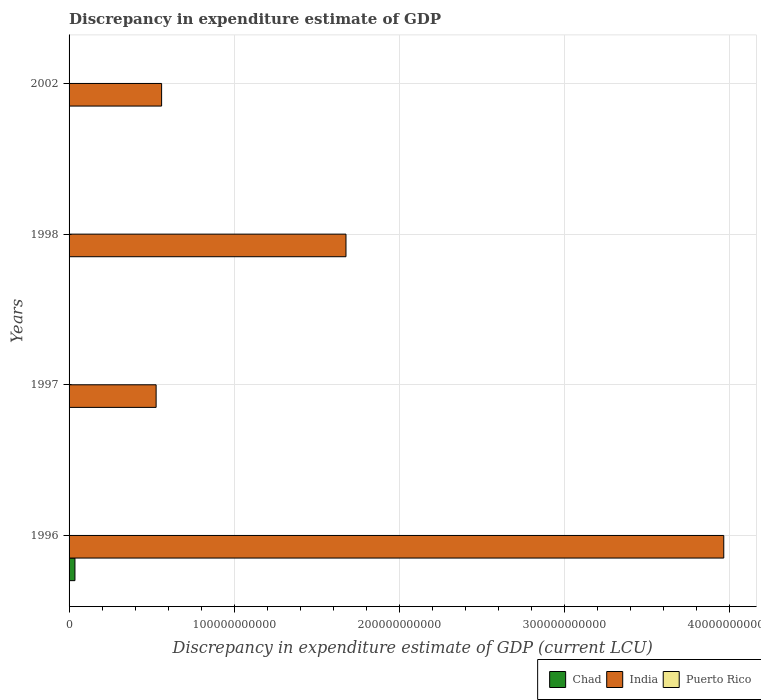How many different coloured bars are there?
Your response must be concise. 3. Are the number of bars on each tick of the Y-axis equal?
Your answer should be compact. No. What is the discrepancy in expenditure estimate of GDP in Chad in 1996?
Make the answer very short. 3.56e+09. Across all years, what is the maximum discrepancy in expenditure estimate of GDP in Chad?
Offer a very short reply. 3.56e+09. What is the total discrepancy in expenditure estimate of GDP in Puerto Rico in the graph?
Your response must be concise. 3.14e+05. What is the difference between the discrepancy in expenditure estimate of GDP in Puerto Rico in 1996 and that in 1997?
Offer a terse response. 7.70e+04. What is the difference between the discrepancy in expenditure estimate of GDP in India in 1997 and the discrepancy in expenditure estimate of GDP in Puerto Rico in 2002?
Your answer should be compact. 5.27e+1. What is the average discrepancy in expenditure estimate of GDP in India per year?
Provide a succinct answer. 1.68e+11. In the year 1996, what is the difference between the discrepancy in expenditure estimate of GDP in Chad and discrepancy in expenditure estimate of GDP in Puerto Rico?
Give a very brief answer. 3.56e+09. What is the difference between the highest and the second highest discrepancy in expenditure estimate of GDP in India?
Your answer should be compact. 2.29e+11. In how many years, is the discrepancy in expenditure estimate of GDP in India greater than the average discrepancy in expenditure estimate of GDP in India taken over all years?
Your answer should be compact. 1. Is it the case that in every year, the sum of the discrepancy in expenditure estimate of GDP in Puerto Rico and discrepancy in expenditure estimate of GDP in Chad is greater than the discrepancy in expenditure estimate of GDP in India?
Your answer should be very brief. No. How many years are there in the graph?
Your response must be concise. 4. What is the difference between two consecutive major ticks on the X-axis?
Provide a succinct answer. 1.00e+11. Are the values on the major ticks of X-axis written in scientific E-notation?
Offer a terse response. No. Does the graph contain any zero values?
Keep it short and to the point. Yes. How many legend labels are there?
Your answer should be very brief. 3. What is the title of the graph?
Offer a terse response. Discrepancy in expenditure estimate of GDP. What is the label or title of the X-axis?
Ensure brevity in your answer.  Discrepancy in expenditure estimate of GDP (current LCU). What is the label or title of the Y-axis?
Give a very brief answer. Years. What is the Discrepancy in expenditure estimate of GDP (current LCU) of Chad in 1996?
Give a very brief answer. 3.56e+09. What is the Discrepancy in expenditure estimate of GDP (current LCU) of India in 1996?
Your answer should be very brief. 3.97e+11. What is the Discrepancy in expenditure estimate of GDP (current LCU) in Puerto Rico in 1996?
Ensure brevity in your answer.  1.40e+05. What is the Discrepancy in expenditure estimate of GDP (current LCU) in Chad in 1997?
Your response must be concise. 0. What is the Discrepancy in expenditure estimate of GDP (current LCU) in India in 1997?
Offer a terse response. 5.27e+1. What is the Discrepancy in expenditure estimate of GDP (current LCU) of Puerto Rico in 1997?
Your response must be concise. 6.30e+04. What is the Discrepancy in expenditure estimate of GDP (current LCU) of India in 1998?
Offer a very short reply. 1.68e+11. What is the Discrepancy in expenditure estimate of GDP (current LCU) in Puerto Rico in 1998?
Your answer should be very brief. 1.11e+05. What is the Discrepancy in expenditure estimate of GDP (current LCU) of Chad in 2002?
Keep it short and to the point. 100. What is the Discrepancy in expenditure estimate of GDP (current LCU) of India in 2002?
Your answer should be compact. 5.61e+1. Across all years, what is the maximum Discrepancy in expenditure estimate of GDP (current LCU) in Chad?
Offer a terse response. 3.56e+09. Across all years, what is the maximum Discrepancy in expenditure estimate of GDP (current LCU) in India?
Ensure brevity in your answer.  3.97e+11. Across all years, what is the minimum Discrepancy in expenditure estimate of GDP (current LCU) of Chad?
Provide a succinct answer. 0. Across all years, what is the minimum Discrepancy in expenditure estimate of GDP (current LCU) of India?
Your response must be concise. 5.27e+1. What is the total Discrepancy in expenditure estimate of GDP (current LCU) in Chad in the graph?
Make the answer very short. 3.56e+09. What is the total Discrepancy in expenditure estimate of GDP (current LCU) of India in the graph?
Make the answer very short. 6.73e+11. What is the total Discrepancy in expenditure estimate of GDP (current LCU) of Puerto Rico in the graph?
Your answer should be compact. 3.14e+05. What is the difference between the Discrepancy in expenditure estimate of GDP (current LCU) in India in 1996 and that in 1997?
Provide a short and direct response. 3.44e+11. What is the difference between the Discrepancy in expenditure estimate of GDP (current LCU) of Puerto Rico in 1996 and that in 1997?
Your response must be concise. 7.70e+04. What is the difference between the Discrepancy in expenditure estimate of GDP (current LCU) of India in 1996 and that in 1998?
Offer a very short reply. 2.29e+11. What is the difference between the Discrepancy in expenditure estimate of GDP (current LCU) in Puerto Rico in 1996 and that in 1998?
Offer a terse response. 2.90e+04. What is the difference between the Discrepancy in expenditure estimate of GDP (current LCU) in Chad in 1996 and that in 2002?
Provide a succinct answer. 3.56e+09. What is the difference between the Discrepancy in expenditure estimate of GDP (current LCU) in India in 1996 and that in 2002?
Your response must be concise. 3.41e+11. What is the difference between the Discrepancy in expenditure estimate of GDP (current LCU) in India in 1997 and that in 1998?
Provide a succinct answer. -1.15e+11. What is the difference between the Discrepancy in expenditure estimate of GDP (current LCU) of Puerto Rico in 1997 and that in 1998?
Keep it short and to the point. -4.80e+04. What is the difference between the Discrepancy in expenditure estimate of GDP (current LCU) of India in 1997 and that in 2002?
Offer a terse response. -3.33e+09. What is the difference between the Discrepancy in expenditure estimate of GDP (current LCU) in India in 1998 and that in 2002?
Keep it short and to the point. 1.12e+11. What is the difference between the Discrepancy in expenditure estimate of GDP (current LCU) in Chad in 1996 and the Discrepancy in expenditure estimate of GDP (current LCU) in India in 1997?
Your response must be concise. -4.92e+1. What is the difference between the Discrepancy in expenditure estimate of GDP (current LCU) in Chad in 1996 and the Discrepancy in expenditure estimate of GDP (current LCU) in Puerto Rico in 1997?
Your answer should be very brief. 3.56e+09. What is the difference between the Discrepancy in expenditure estimate of GDP (current LCU) in India in 1996 and the Discrepancy in expenditure estimate of GDP (current LCU) in Puerto Rico in 1997?
Make the answer very short. 3.97e+11. What is the difference between the Discrepancy in expenditure estimate of GDP (current LCU) of Chad in 1996 and the Discrepancy in expenditure estimate of GDP (current LCU) of India in 1998?
Offer a terse response. -1.64e+11. What is the difference between the Discrepancy in expenditure estimate of GDP (current LCU) of Chad in 1996 and the Discrepancy in expenditure estimate of GDP (current LCU) of Puerto Rico in 1998?
Offer a very short reply. 3.56e+09. What is the difference between the Discrepancy in expenditure estimate of GDP (current LCU) of India in 1996 and the Discrepancy in expenditure estimate of GDP (current LCU) of Puerto Rico in 1998?
Give a very brief answer. 3.97e+11. What is the difference between the Discrepancy in expenditure estimate of GDP (current LCU) of Chad in 1996 and the Discrepancy in expenditure estimate of GDP (current LCU) of India in 2002?
Provide a succinct answer. -5.25e+1. What is the difference between the Discrepancy in expenditure estimate of GDP (current LCU) of India in 1997 and the Discrepancy in expenditure estimate of GDP (current LCU) of Puerto Rico in 1998?
Give a very brief answer. 5.27e+1. What is the average Discrepancy in expenditure estimate of GDP (current LCU) in Chad per year?
Ensure brevity in your answer.  8.91e+08. What is the average Discrepancy in expenditure estimate of GDP (current LCU) in India per year?
Offer a terse response. 1.68e+11. What is the average Discrepancy in expenditure estimate of GDP (current LCU) in Puerto Rico per year?
Your answer should be very brief. 7.85e+04. In the year 1996, what is the difference between the Discrepancy in expenditure estimate of GDP (current LCU) of Chad and Discrepancy in expenditure estimate of GDP (current LCU) of India?
Give a very brief answer. -3.93e+11. In the year 1996, what is the difference between the Discrepancy in expenditure estimate of GDP (current LCU) of Chad and Discrepancy in expenditure estimate of GDP (current LCU) of Puerto Rico?
Provide a succinct answer. 3.56e+09. In the year 1996, what is the difference between the Discrepancy in expenditure estimate of GDP (current LCU) in India and Discrepancy in expenditure estimate of GDP (current LCU) in Puerto Rico?
Keep it short and to the point. 3.97e+11. In the year 1997, what is the difference between the Discrepancy in expenditure estimate of GDP (current LCU) in India and Discrepancy in expenditure estimate of GDP (current LCU) in Puerto Rico?
Provide a short and direct response. 5.27e+1. In the year 1998, what is the difference between the Discrepancy in expenditure estimate of GDP (current LCU) in India and Discrepancy in expenditure estimate of GDP (current LCU) in Puerto Rico?
Ensure brevity in your answer.  1.68e+11. In the year 2002, what is the difference between the Discrepancy in expenditure estimate of GDP (current LCU) in Chad and Discrepancy in expenditure estimate of GDP (current LCU) in India?
Offer a very short reply. -5.61e+1. What is the ratio of the Discrepancy in expenditure estimate of GDP (current LCU) of India in 1996 to that in 1997?
Keep it short and to the point. 7.52. What is the ratio of the Discrepancy in expenditure estimate of GDP (current LCU) of Puerto Rico in 1996 to that in 1997?
Offer a terse response. 2.22. What is the ratio of the Discrepancy in expenditure estimate of GDP (current LCU) of India in 1996 to that in 1998?
Your answer should be compact. 2.36. What is the ratio of the Discrepancy in expenditure estimate of GDP (current LCU) of Puerto Rico in 1996 to that in 1998?
Keep it short and to the point. 1.26. What is the ratio of the Discrepancy in expenditure estimate of GDP (current LCU) in Chad in 1996 to that in 2002?
Your response must be concise. 3.56e+07. What is the ratio of the Discrepancy in expenditure estimate of GDP (current LCU) in India in 1996 to that in 2002?
Provide a succinct answer. 7.07. What is the ratio of the Discrepancy in expenditure estimate of GDP (current LCU) of India in 1997 to that in 1998?
Ensure brevity in your answer.  0.31. What is the ratio of the Discrepancy in expenditure estimate of GDP (current LCU) of Puerto Rico in 1997 to that in 1998?
Your answer should be compact. 0.57. What is the ratio of the Discrepancy in expenditure estimate of GDP (current LCU) in India in 1997 to that in 2002?
Provide a short and direct response. 0.94. What is the ratio of the Discrepancy in expenditure estimate of GDP (current LCU) of India in 1998 to that in 2002?
Keep it short and to the point. 2.99. What is the difference between the highest and the second highest Discrepancy in expenditure estimate of GDP (current LCU) in India?
Ensure brevity in your answer.  2.29e+11. What is the difference between the highest and the second highest Discrepancy in expenditure estimate of GDP (current LCU) of Puerto Rico?
Offer a terse response. 2.90e+04. What is the difference between the highest and the lowest Discrepancy in expenditure estimate of GDP (current LCU) in Chad?
Offer a terse response. 3.56e+09. What is the difference between the highest and the lowest Discrepancy in expenditure estimate of GDP (current LCU) of India?
Your answer should be compact. 3.44e+11. 